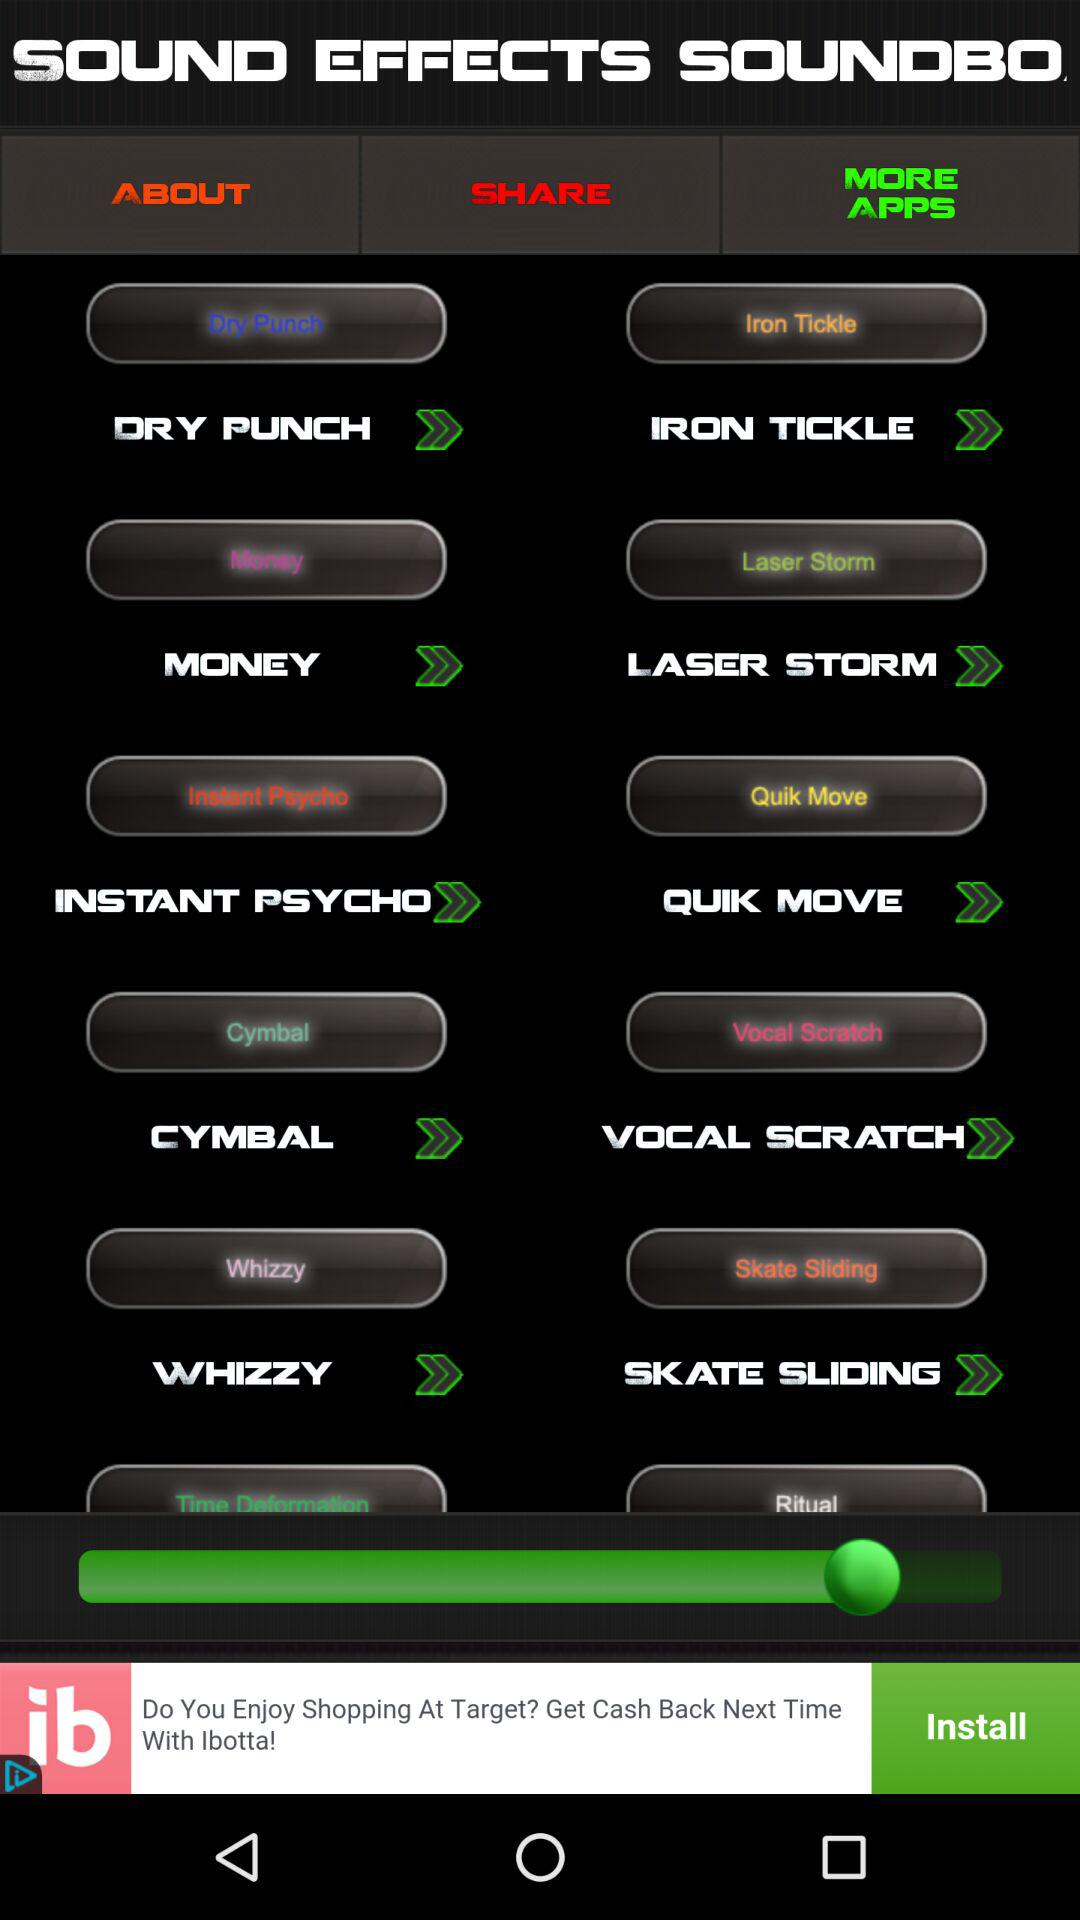What is the application name? The application name is "SOUND EFFECTS SOUNDBO". 